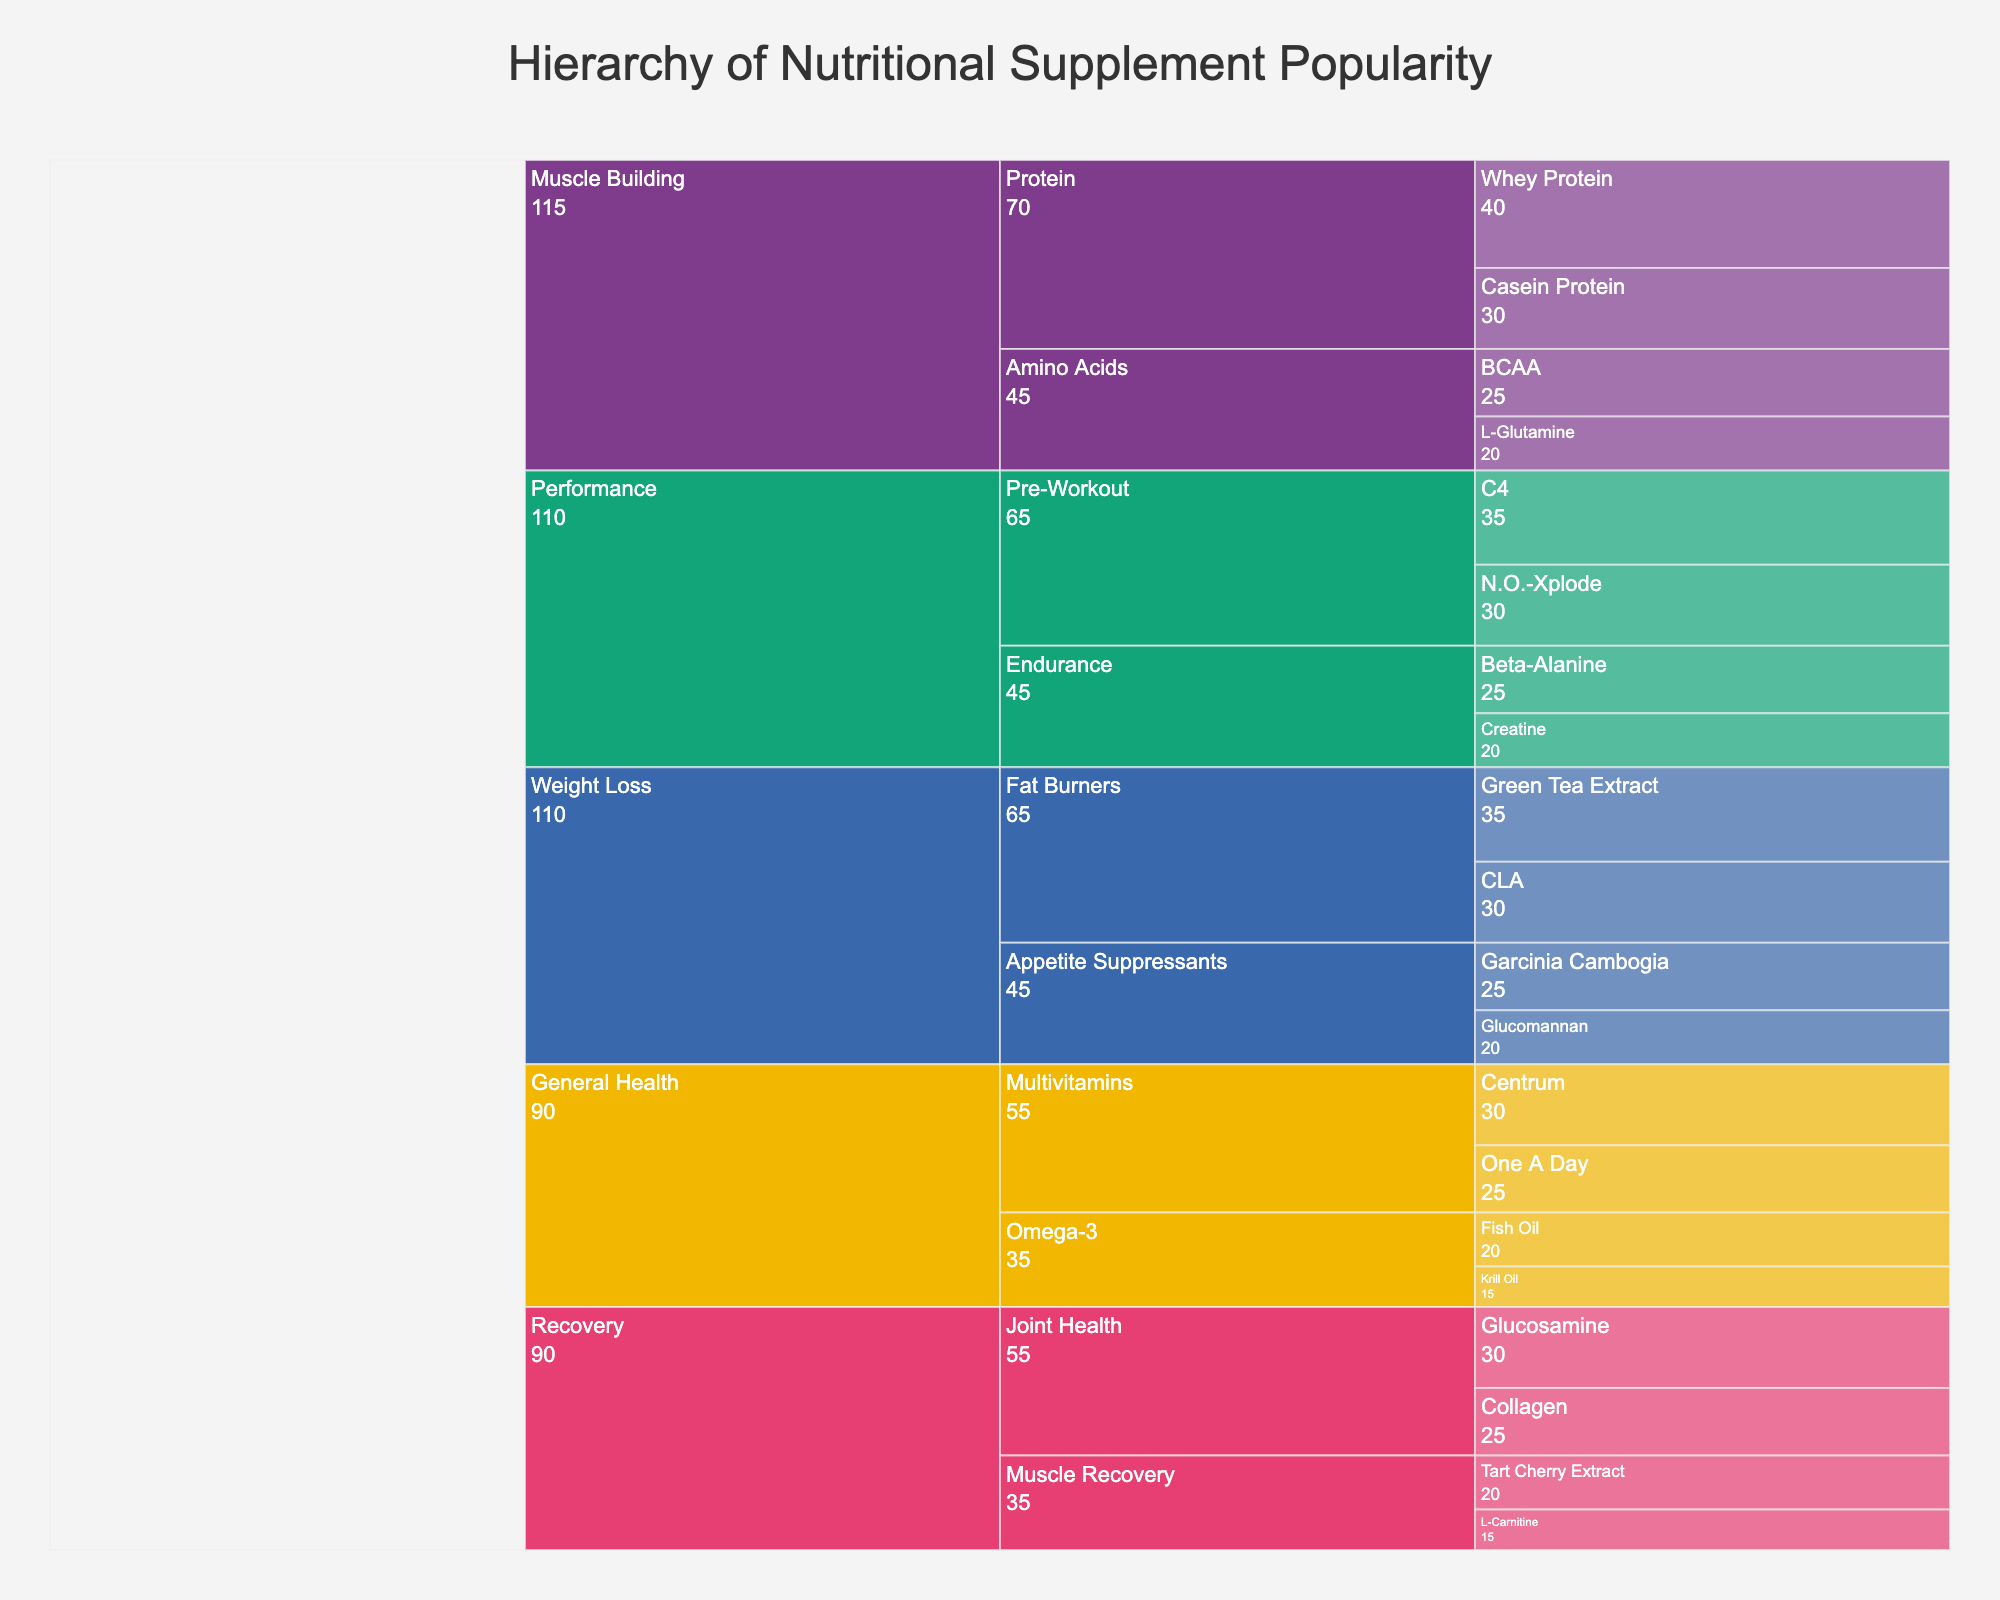What's the title of the icicle chart? The title is usually located at the top center of the figure. In this case, the title given in the code is "Hierarchy of Nutritional Supplement Popularity."
Answer: Hierarchy of Nutritional Supplement Popularity How is the data color-coded? The chart assigns different colors to different categories. Categories such as General Health, Muscle Building, Weight Loss, Performance, and Recovery are each represented by a unique color from the qualitative Bold color sequence.
Answer: By Category Which supplement has the highest popularity across all categories? To find this, look at the values associated with each supplement in the chart. "Whey Protein" under the "Muscle Building" category has the highest popularity value of 40.
Answer: Whey Protein What's the total popularity value for the "Performance" category? Sum the popularity values of all the supplements under the "Performance" category: C4 (35) + N.O.-Xplode (30) + Beta-Alanine (25) + Creatine (20). This equals 110.
Answer: 110 How much more popular is "Whey Protein" compared to "Casein Protein"? Find the popularity values for both supplements: Whey Protein (40) and Casein Protein (30). Subtract the two values: 40 - 30 = 10. Whey Protein is 10 units more popular.
Answer: 10 Which supplement in the "General Health" category has the second-highest popularity? Look at the popularity values in the "General Health" category. The highest is Centrum (30), and the second highest is One A Day (25).
Answer: One A Day What's the average popularity of all the supplements under "Muscle Building"? Calculate the average by summing the popularity values for Muscle Building supplements: Whey Protein (40) + Casein Protein (30) + BCAA (25) + L-Glutamine (20) = 115. Then divide by the number of supplements, which is 4. So, 115 / 4 = 28.75.
Answer: 28.75 What is the least popular supplement in the "Recovery" category and its value? Look at the popularity values under the "Recovery" category. The values are: Glucosamine (30), Collagen (25), Tart Cherry Extract (20), and L-Carnitine (15). The least popular is L-Carnitine with a value of 15.
Answer: L-Carnitine, 15 Which specific supplement in the "Appetite Suppressants" subcategory is more popular? Compare the popularity values of supplements in the "Appetite Suppressants" subcategory: Garcinia Cambogia (25) and Glucomannan (20). Garcinia Cambogia is more popular.
Answer: Garcinia Cambogia How many specific supplements are there in the "Pre-Workout" subcategory of the "Performance" category? Count the distinct supplements listed under the "Pre-Workout" subcategory. They are C4 and N.O.-Xplode, thus there are 2 specific supplements.
Answer: 2 